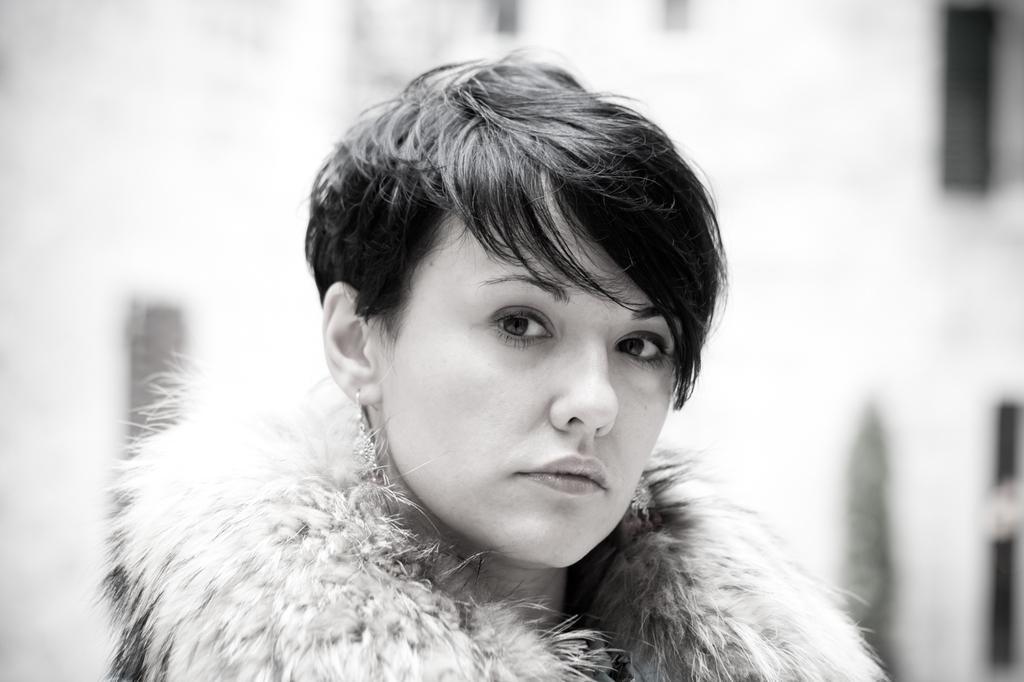How would you summarize this image in a sentence or two? This is a black and white picture. The woman in front of the picture is looking at the camera. Behind her, it is white in color. In the background, it is blurred. 